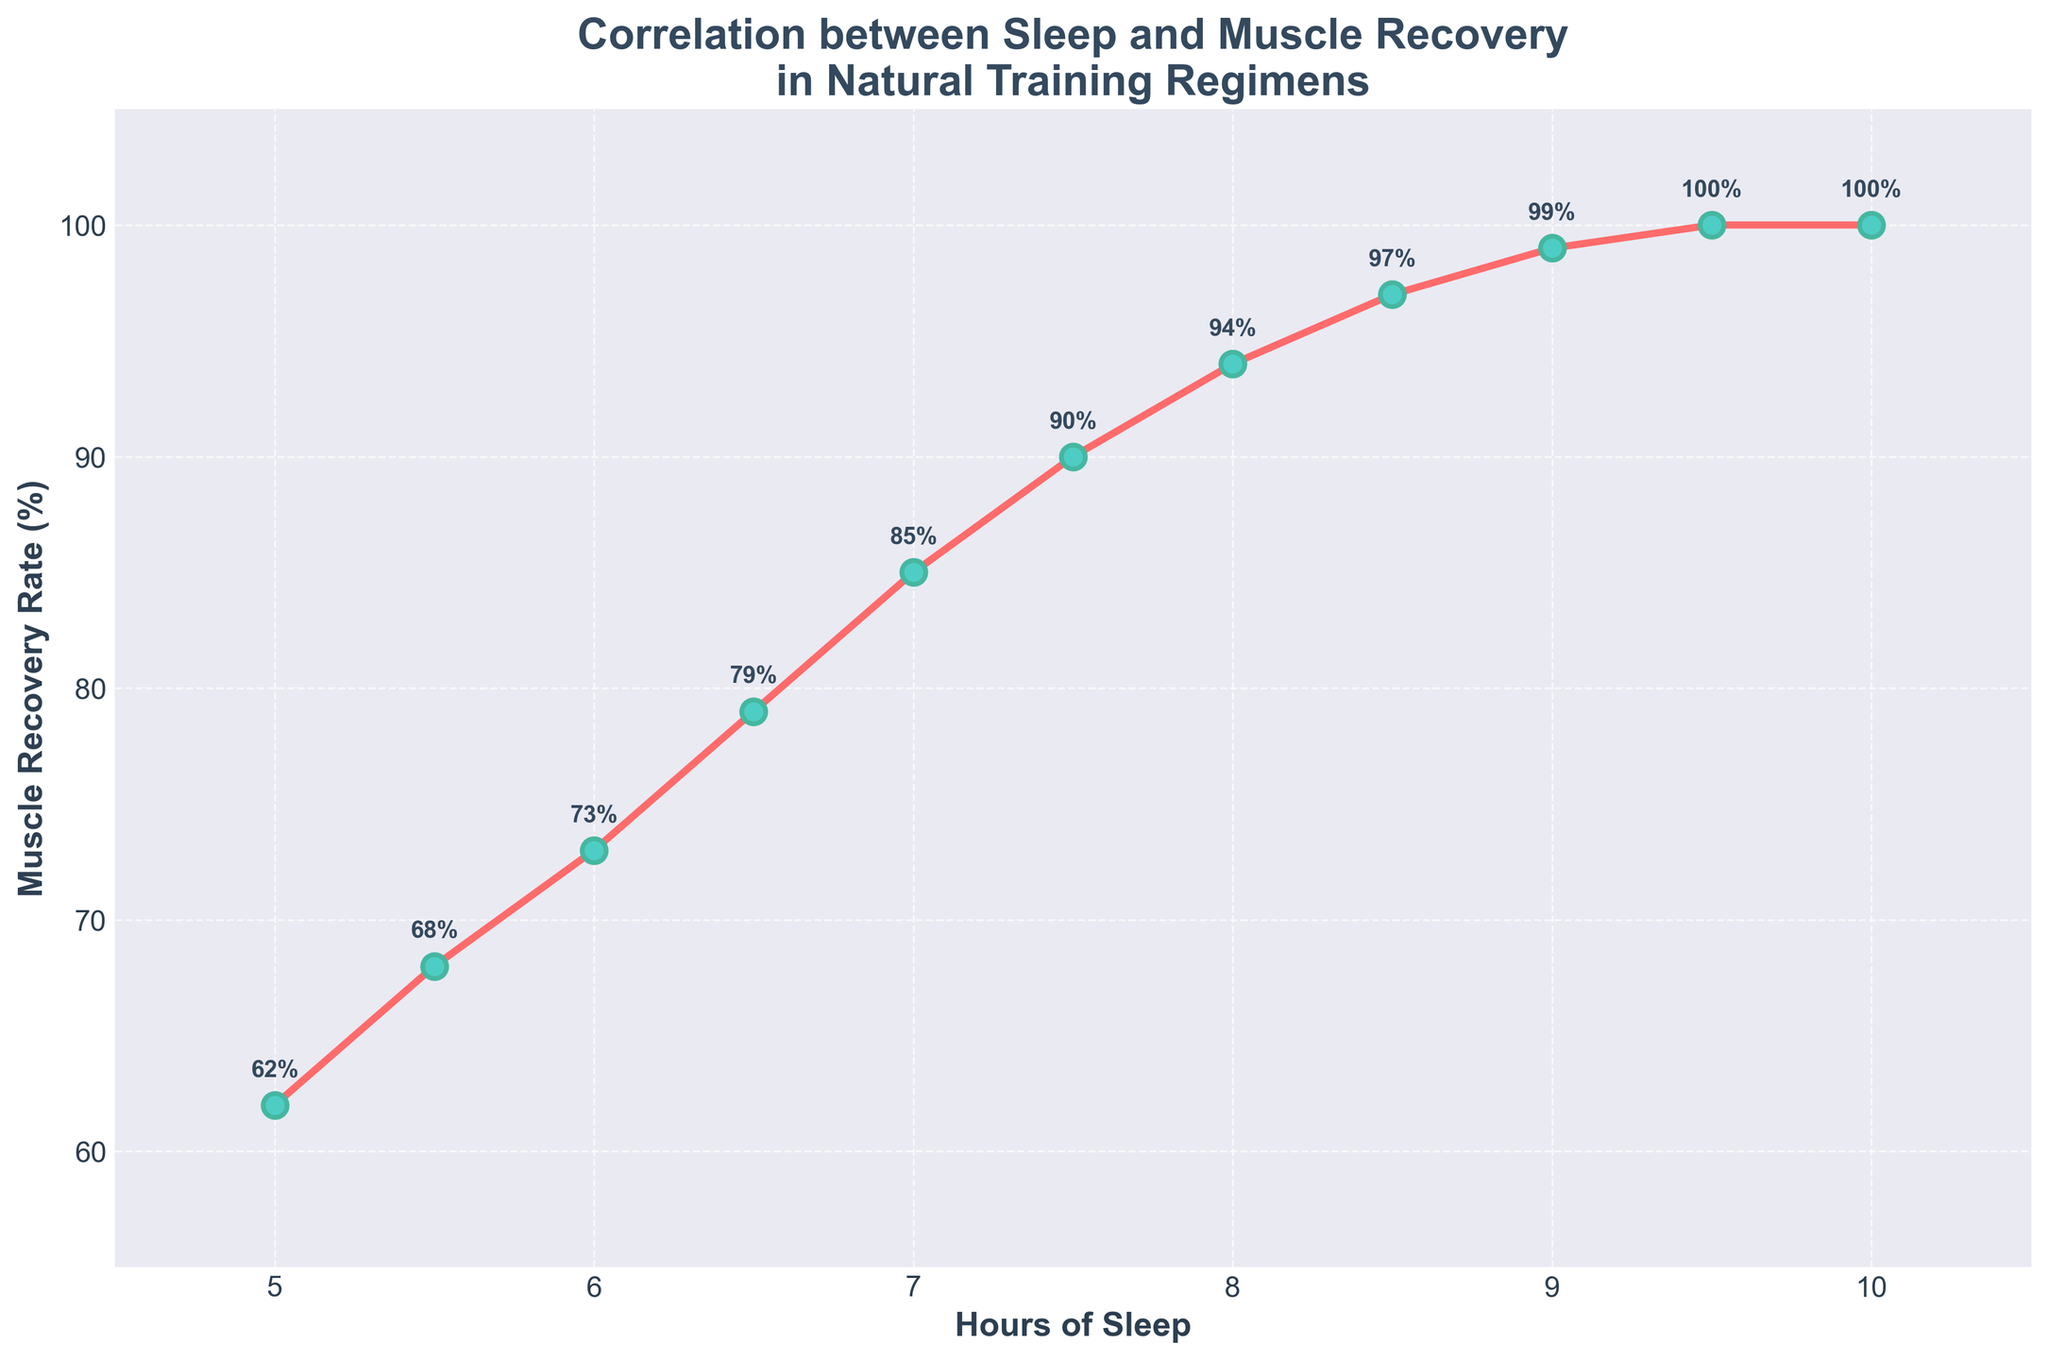What is the muscle recovery rate at 8 hours of sleep? The line chart shows that at the point corresponding to 8 hours of sleep, the muscle recovery rate is labeled as 94%.
Answer: 94% How much does the muscle recovery rate increase from 6 hours to 7 hours of sleep? At 6 hours of sleep, the muscle recovery rate is 73%. At 7 hours of sleep, it is 85%. The increase is 85% - 73% = 12%.
Answer: 12% What is the difference in muscle recovery rates between 5.5 hours and 7.5 hours of sleep? At 5.5 hours of sleep, the recovery rate is 68%. At 7.5 hours, it is 90%. The difference is 90% - 68% = 22%.
Answer: 22% At what point does the muscle recovery rate reach 100%? The chart shows that the muscle recovery rate reaches 100% at both 9.5 and 10 hours of sleep.
Answer: 9.5 and 10 hours What is the average muscle recovery rate between 7 and 9 hours of sleep? The muscle recovery rates at 7, 7.5, 8, 8.5, and 9 hours of sleep are 85%, 90%, 94%, 97%, and 99%, respectively. The average is (85 + 90 + 94 + 97 + 99) / 5 = 465 / 5 = 93%.
Answer: 93% Which sleep duration shows the greatest increase in muscle recovery rate compared to the previous hour? The greatest increase occurs between 6.5 and 7 hours, where the rate increases from 79% to 85%. The increase is 6%.
Answer: 6.5 to 7 hours How many hours of sleep are needed to achieve at least a 90% recovery rate? The muscle recovery rate reaches 90% at 7.5 hours of sleep.
Answer: 7.5 hours Compare the muscle recovery rates at 5 hours and 10 hours of sleep. What is the ratio? At 5 hours, the rate is 62%. At 10 hours, it is 100%. The ratio is 62:100, which simplifies to 31:50.
Answer: 31:50 What can you infer about muscle recovery rate trends from the visual attributes of the plot? The upward trend of the line and the increasing percentage labels indicate that muscle recovery improves with more hours of sleep.
Answer: Improves with more sleep 